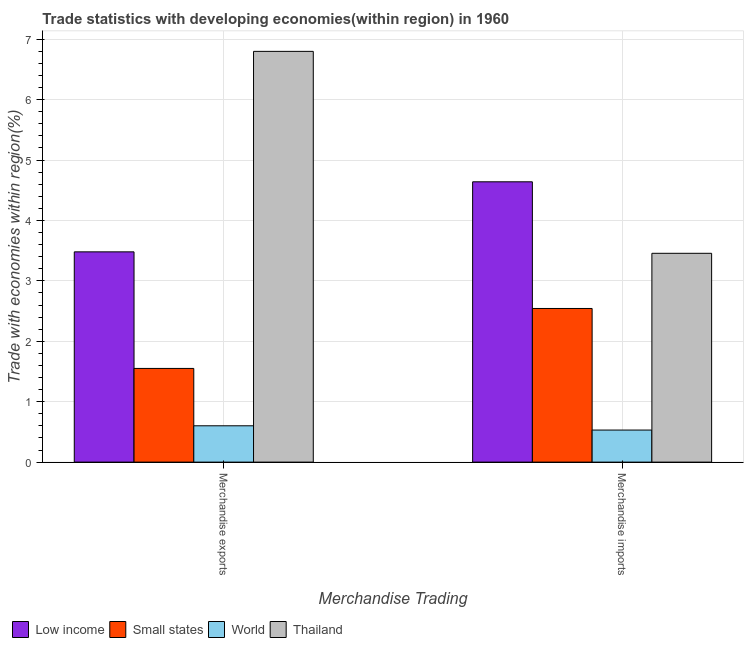How many different coloured bars are there?
Ensure brevity in your answer.  4. How many groups of bars are there?
Keep it short and to the point. 2. Are the number of bars per tick equal to the number of legend labels?
Your answer should be compact. Yes. How many bars are there on the 1st tick from the left?
Your response must be concise. 4. What is the merchandise exports in World?
Provide a succinct answer. 0.6. Across all countries, what is the maximum merchandise exports?
Offer a terse response. 6.8. Across all countries, what is the minimum merchandise imports?
Make the answer very short. 0.53. In which country was the merchandise exports maximum?
Offer a very short reply. Thailand. In which country was the merchandise exports minimum?
Your response must be concise. World. What is the total merchandise exports in the graph?
Offer a terse response. 12.43. What is the difference between the merchandise imports in Low income and that in World?
Make the answer very short. 4.11. What is the difference between the merchandise imports in Small states and the merchandise exports in Thailand?
Your answer should be compact. -4.26. What is the average merchandise imports per country?
Make the answer very short. 2.79. What is the difference between the merchandise exports and merchandise imports in Low income?
Give a very brief answer. -1.16. In how many countries, is the merchandise imports greater than 1 %?
Your answer should be very brief. 3. What is the ratio of the merchandise exports in Thailand to that in Low income?
Offer a very short reply. 1.95. In how many countries, is the merchandise imports greater than the average merchandise imports taken over all countries?
Provide a succinct answer. 2. What does the 4th bar from the left in Merchandise imports represents?
Your answer should be compact. Thailand. What does the 1st bar from the right in Merchandise imports represents?
Your answer should be very brief. Thailand. How many bars are there?
Ensure brevity in your answer.  8. Are all the bars in the graph horizontal?
Offer a very short reply. No. What is the difference between two consecutive major ticks on the Y-axis?
Provide a succinct answer. 1. Are the values on the major ticks of Y-axis written in scientific E-notation?
Provide a short and direct response. No. Does the graph contain any zero values?
Provide a succinct answer. No. Where does the legend appear in the graph?
Provide a short and direct response. Bottom left. What is the title of the graph?
Offer a very short reply. Trade statistics with developing economies(within region) in 1960. Does "Venezuela" appear as one of the legend labels in the graph?
Ensure brevity in your answer.  No. What is the label or title of the X-axis?
Your answer should be compact. Merchandise Trading. What is the label or title of the Y-axis?
Provide a short and direct response. Trade with economies within region(%). What is the Trade with economies within region(%) in Low income in Merchandise exports?
Provide a short and direct response. 3.48. What is the Trade with economies within region(%) in Small states in Merchandise exports?
Give a very brief answer. 1.55. What is the Trade with economies within region(%) of World in Merchandise exports?
Your response must be concise. 0.6. What is the Trade with economies within region(%) in Thailand in Merchandise exports?
Offer a terse response. 6.8. What is the Trade with economies within region(%) of Low income in Merchandise imports?
Your answer should be very brief. 4.64. What is the Trade with economies within region(%) in Small states in Merchandise imports?
Offer a terse response. 2.54. What is the Trade with economies within region(%) in World in Merchandise imports?
Make the answer very short. 0.53. What is the Trade with economies within region(%) in Thailand in Merchandise imports?
Offer a very short reply. 3.46. Across all Merchandise Trading, what is the maximum Trade with economies within region(%) of Low income?
Your answer should be compact. 4.64. Across all Merchandise Trading, what is the maximum Trade with economies within region(%) in Small states?
Ensure brevity in your answer.  2.54. Across all Merchandise Trading, what is the maximum Trade with economies within region(%) in World?
Ensure brevity in your answer.  0.6. Across all Merchandise Trading, what is the maximum Trade with economies within region(%) in Thailand?
Provide a short and direct response. 6.8. Across all Merchandise Trading, what is the minimum Trade with economies within region(%) of Low income?
Give a very brief answer. 3.48. Across all Merchandise Trading, what is the minimum Trade with economies within region(%) in Small states?
Offer a terse response. 1.55. Across all Merchandise Trading, what is the minimum Trade with economies within region(%) in World?
Provide a succinct answer. 0.53. Across all Merchandise Trading, what is the minimum Trade with economies within region(%) of Thailand?
Offer a very short reply. 3.46. What is the total Trade with economies within region(%) of Low income in the graph?
Your response must be concise. 8.12. What is the total Trade with economies within region(%) in Small states in the graph?
Keep it short and to the point. 4.09. What is the total Trade with economies within region(%) of World in the graph?
Make the answer very short. 1.13. What is the total Trade with economies within region(%) of Thailand in the graph?
Your answer should be very brief. 10.25. What is the difference between the Trade with economies within region(%) in Low income in Merchandise exports and that in Merchandise imports?
Ensure brevity in your answer.  -1.16. What is the difference between the Trade with economies within region(%) in Small states in Merchandise exports and that in Merchandise imports?
Provide a short and direct response. -0.99. What is the difference between the Trade with economies within region(%) in World in Merchandise exports and that in Merchandise imports?
Your answer should be very brief. 0.07. What is the difference between the Trade with economies within region(%) in Thailand in Merchandise exports and that in Merchandise imports?
Provide a short and direct response. 3.34. What is the difference between the Trade with economies within region(%) of Low income in Merchandise exports and the Trade with economies within region(%) of Small states in Merchandise imports?
Make the answer very short. 0.94. What is the difference between the Trade with economies within region(%) of Low income in Merchandise exports and the Trade with economies within region(%) of World in Merchandise imports?
Keep it short and to the point. 2.95. What is the difference between the Trade with economies within region(%) of Low income in Merchandise exports and the Trade with economies within region(%) of Thailand in Merchandise imports?
Give a very brief answer. 0.02. What is the difference between the Trade with economies within region(%) in Small states in Merchandise exports and the Trade with economies within region(%) in World in Merchandise imports?
Offer a terse response. 1.02. What is the difference between the Trade with economies within region(%) of Small states in Merchandise exports and the Trade with economies within region(%) of Thailand in Merchandise imports?
Ensure brevity in your answer.  -1.91. What is the difference between the Trade with economies within region(%) of World in Merchandise exports and the Trade with economies within region(%) of Thailand in Merchandise imports?
Keep it short and to the point. -2.85. What is the average Trade with economies within region(%) in Low income per Merchandise Trading?
Offer a very short reply. 4.06. What is the average Trade with economies within region(%) in Small states per Merchandise Trading?
Offer a very short reply. 2.05. What is the average Trade with economies within region(%) in World per Merchandise Trading?
Provide a succinct answer. 0.57. What is the average Trade with economies within region(%) in Thailand per Merchandise Trading?
Provide a short and direct response. 5.13. What is the difference between the Trade with economies within region(%) in Low income and Trade with economies within region(%) in Small states in Merchandise exports?
Ensure brevity in your answer.  1.93. What is the difference between the Trade with economies within region(%) in Low income and Trade with economies within region(%) in World in Merchandise exports?
Give a very brief answer. 2.88. What is the difference between the Trade with economies within region(%) of Low income and Trade with economies within region(%) of Thailand in Merchandise exports?
Offer a very short reply. -3.32. What is the difference between the Trade with economies within region(%) of Small states and Trade with economies within region(%) of World in Merchandise exports?
Give a very brief answer. 0.95. What is the difference between the Trade with economies within region(%) of Small states and Trade with economies within region(%) of Thailand in Merchandise exports?
Give a very brief answer. -5.25. What is the difference between the Trade with economies within region(%) of World and Trade with economies within region(%) of Thailand in Merchandise exports?
Ensure brevity in your answer.  -6.2. What is the difference between the Trade with economies within region(%) of Low income and Trade with economies within region(%) of Small states in Merchandise imports?
Your answer should be very brief. 2.1. What is the difference between the Trade with economies within region(%) of Low income and Trade with economies within region(%) of World in Merchandise imports?
Keep it short and to the point. 4.11. What is the difference between the Trade with economies within region(%) of Low income and Trade with economies within region(%) of Thailand in Merchandise imports?
Offer a very short reply. 1.18. What is the difference between the Trade with economies within region(%) in Small states and Trade with economies within region(%) in World in Merchandise imports?
Your response must be concise. 2.01. What is the difference between the Trade with economies within region(%) in Small states and Trade with economies within region(%) in Thailand in Merchandise imports?
Your answer should be compact. -0.91. What is the difference between the Trade with economies within region(%) of World and Trade with economies within region(%) of Thailand in Merchandise imports?
Ensure brevity in your answer.  -2.93. What is the ratio of the Trade with economies within region(%) of Low income in Merchandise exports to that in Merchandise imports?
Ensure brevity in your answer.  0.75. What is the ratio of the Trade with economies within region(%) of Small states in Merchandise exports to that in Merchandise imports?
Provide a succinct answer. 0.61. What is the ratio of the Trade with economies within region(%) in World in Merchandise exports to that in Merchandise imports?
Your answer should be compact. 1.13. What is the ratio of the Trade with economies within region(%) of Thailand in Merchandise exports to that in Merchandise imports?
Provide a short and direct response. 1.97. What is the difference between the highest and the second highest Trade with economies within region(%) of Low income?
Ensure brevity in your answer.  1.16. What is the difference between the highest and the second highest Trade with economies within region(%) of World?
Make the answer very short. 0.07. What is the difference between the highest and the second highest Trade with economies within region(%) in Thailand?
Give a very brief answer. 3.34. What is the difference between the highest and the lowest Trade with economies within region(%) in Low income?
Keep it short and to the point. 1.16. What is the difference between the highest and the lowest Trade with economies within region(%) in Small states?
Your answer should be compact. 0.99. What is the difference between the highest and the lowest Trade with economies within region(%) in World?
Provide a succinct answer. 0.07. What is the difference between the highest and the lowest Trade with economies within region(%) of Thailand?
Offer a very short reply. 3.34. 